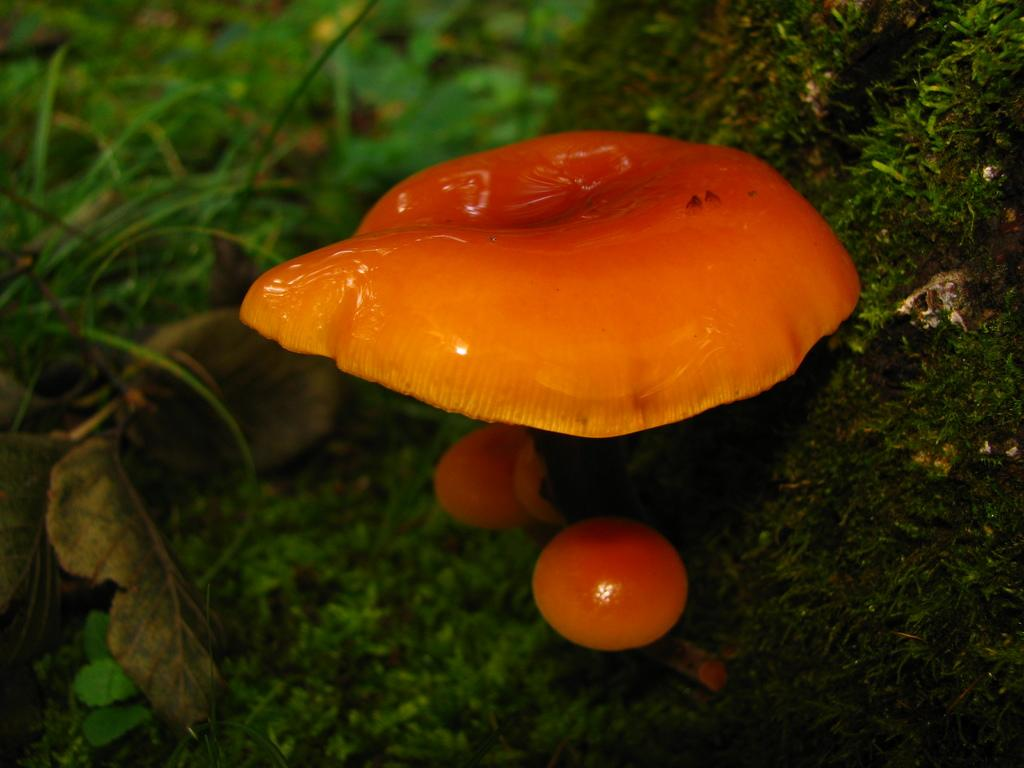What type of fungi can be seen in the image? There are mushrooms in the image. What type of vegetation is present on the surface at the bottom of the image? There is grass on the surface at the bottom of the image. What type of trousers are being worn by the mushrooms in the image? There are no trousers present in the image, as mushrooms do not wear clothing. Can you hear the drum being played by the grass in the image? There is no drum or sound present in the image, as it is a still photograph. 